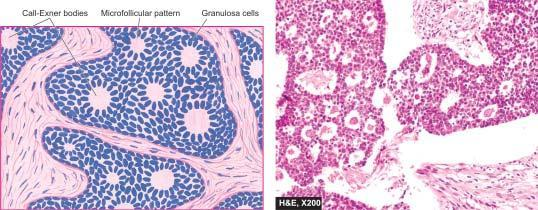what is surrounded by granulosa cells?
Answer the question using a single word or phrase. Central amorphous pink material 